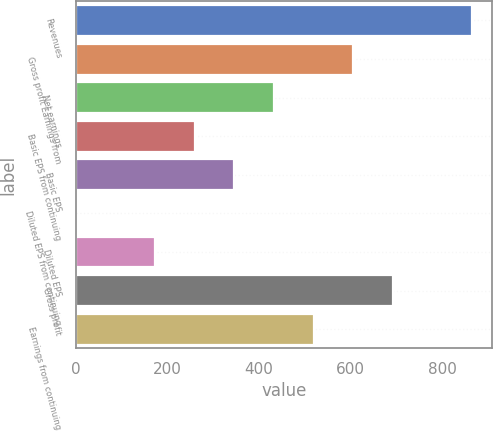Convert chart. <chart><loc_0><loc_0><loc_500><loc_500><bar_chart><fcel>Revenues<fcel>Gross profit Earnings from<fcel>Net earnings<fcel>Basic EPS from continuing<fcel>Basic EPS<fcel>Diluted EPS from continuing<fcel>Diluted EPS<fcel>Gross profit<fcel>Earnings from continuing<nl><fcel>865.1<fcel>605.78<fcel>432.88<fcel>260<fcel>346.44<fcel>0.65<fcel>173.55<fcel>692.23<fcel>519.33<nl></chart> 